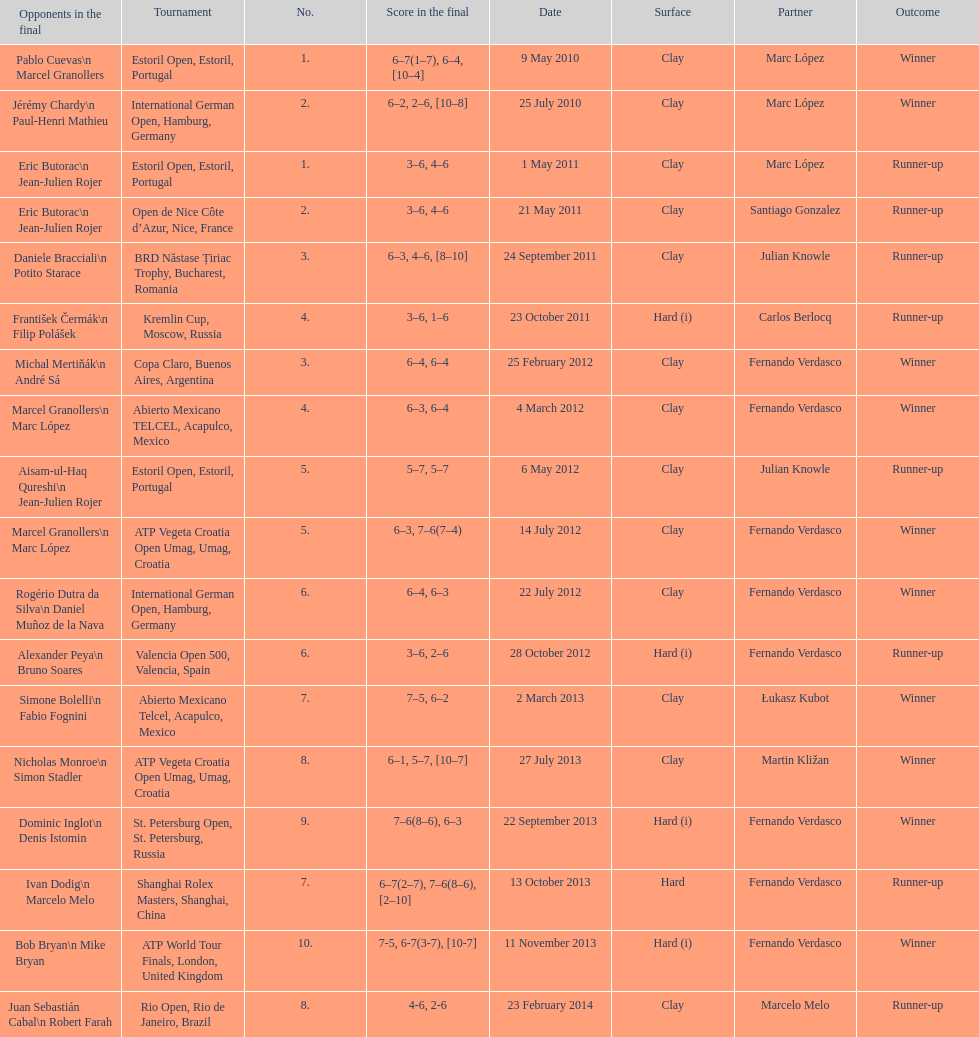What is the number of times a hard surface was used? 5. 